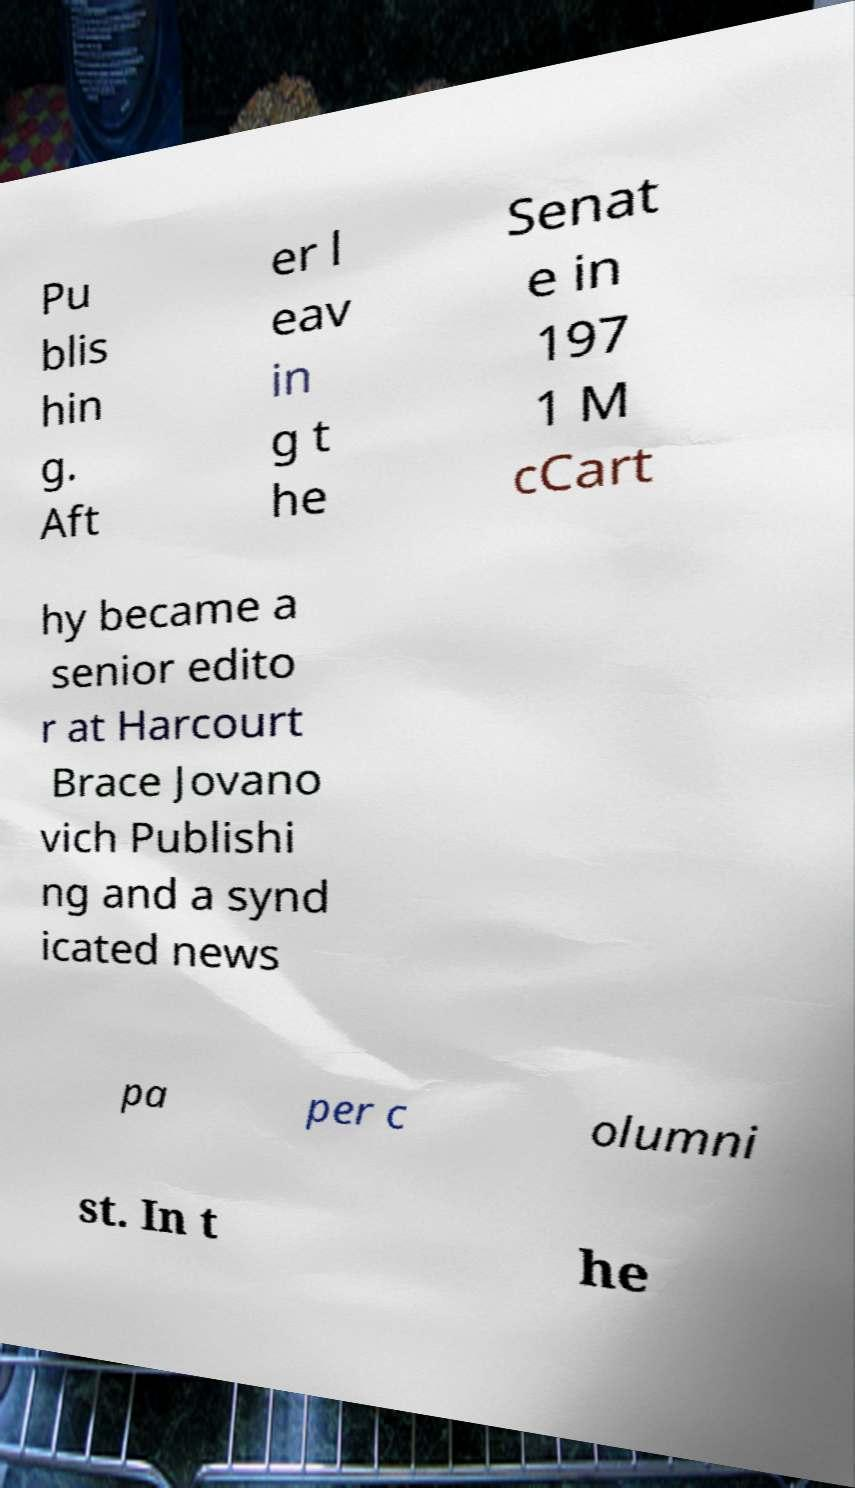Could you assist in decoding the text presented in this image and type it out clearly? Pu blis hin g. Aft er l eav in g t he Senat e in 197 1 M cCart hy became a senior edito r at Harcourt Brace Jovano vich Publishi ng and a synd icated news pa per c olumni st. In t he 